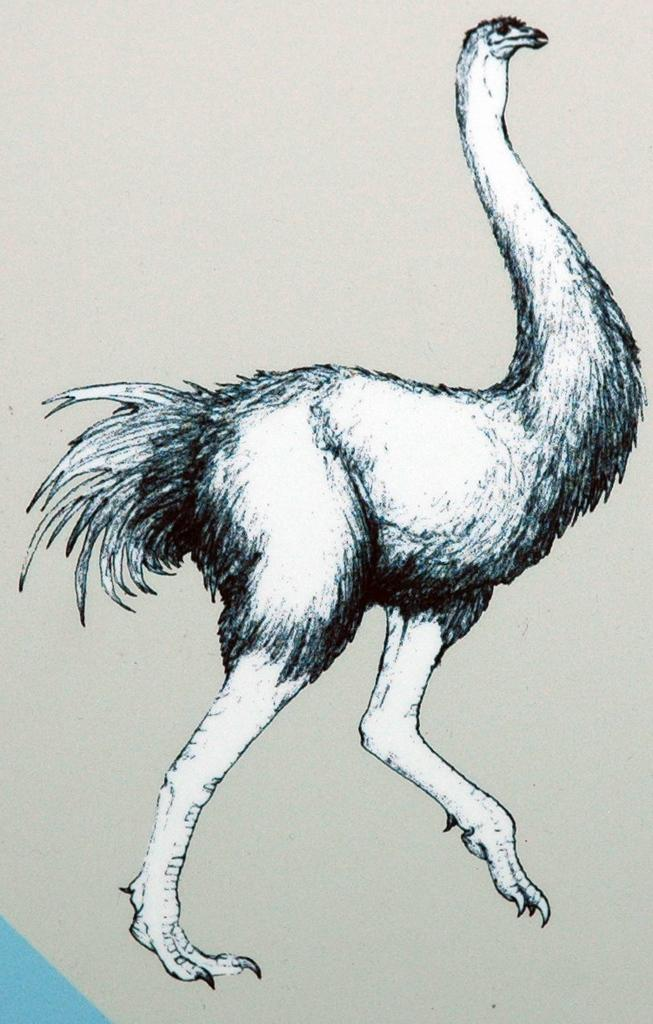What is the main subject of the painting in the image? There is a painting of an ostrich in the image. What type of underwear is the ostrich wearing in the painting? There is no underwear present in the painting, as ostriches do not wear clothing. 